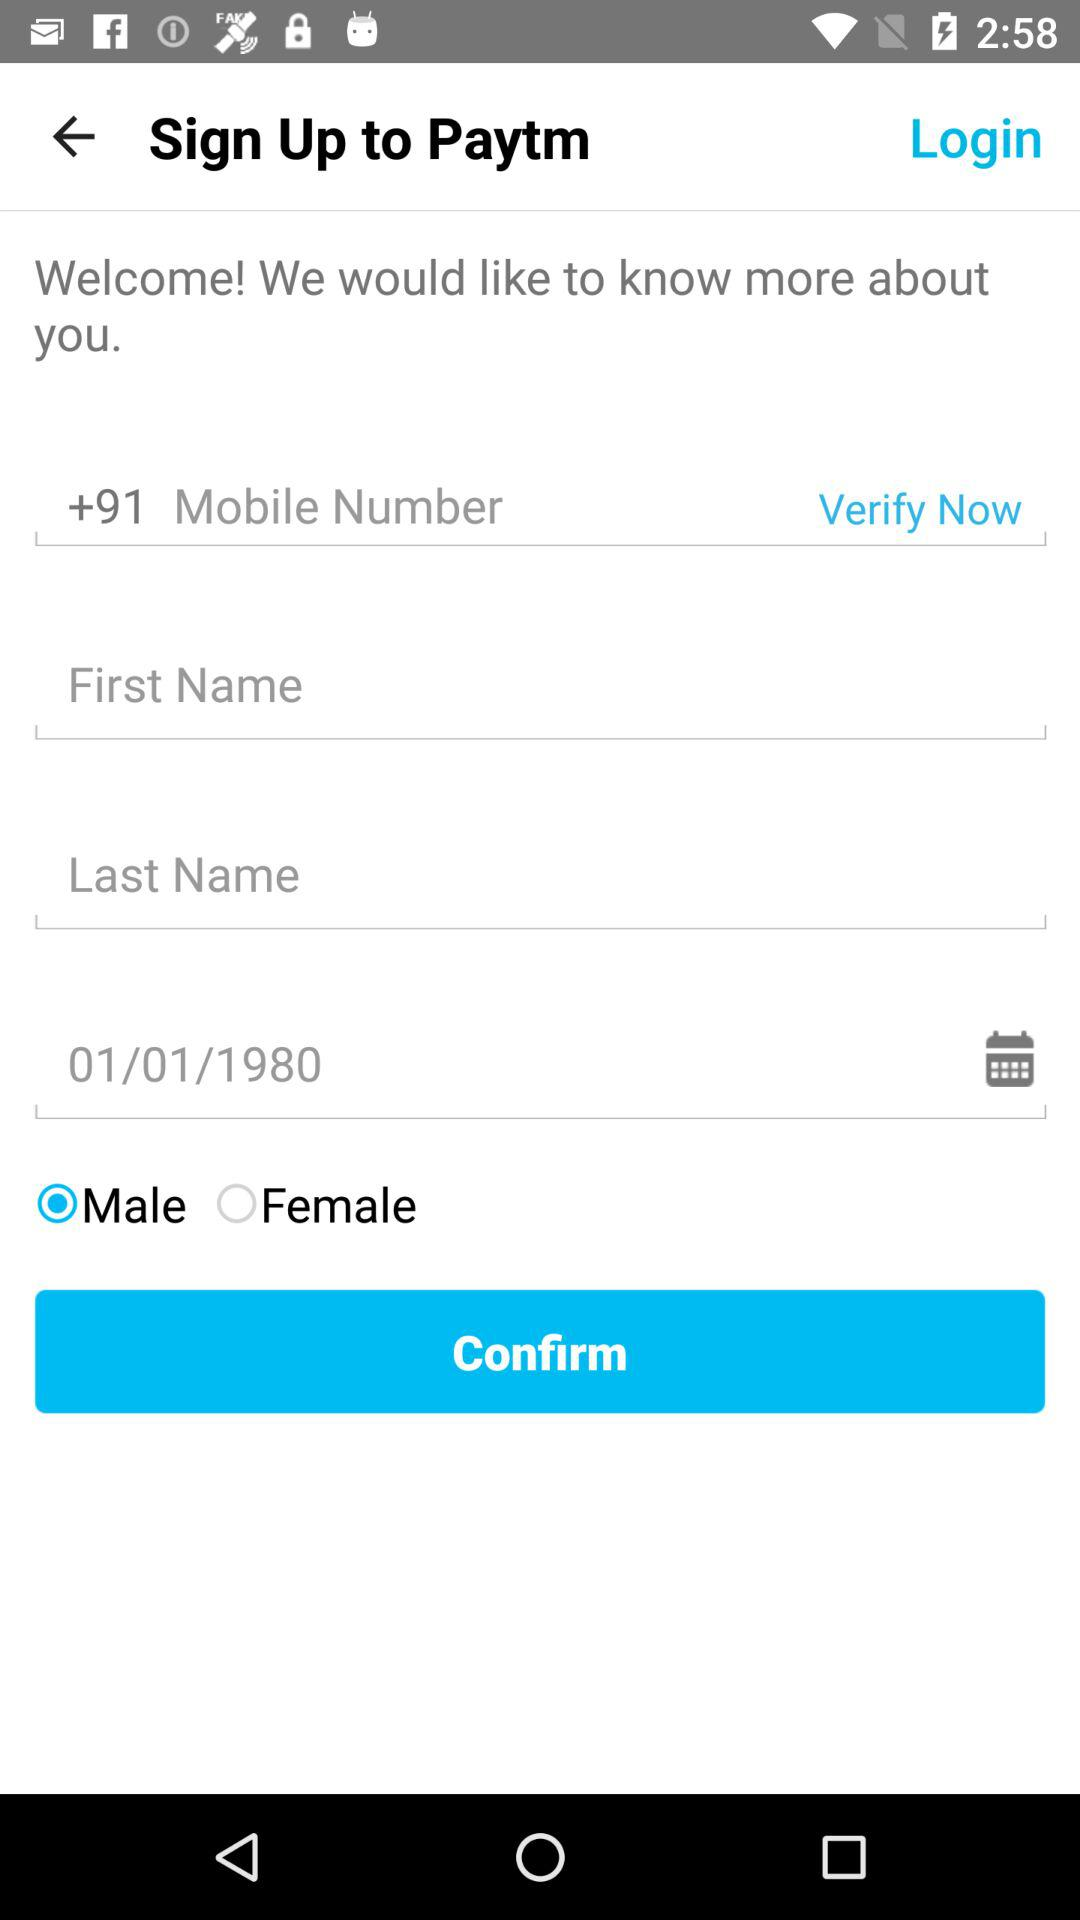What is the gender of the person? The gender of the person is male. 